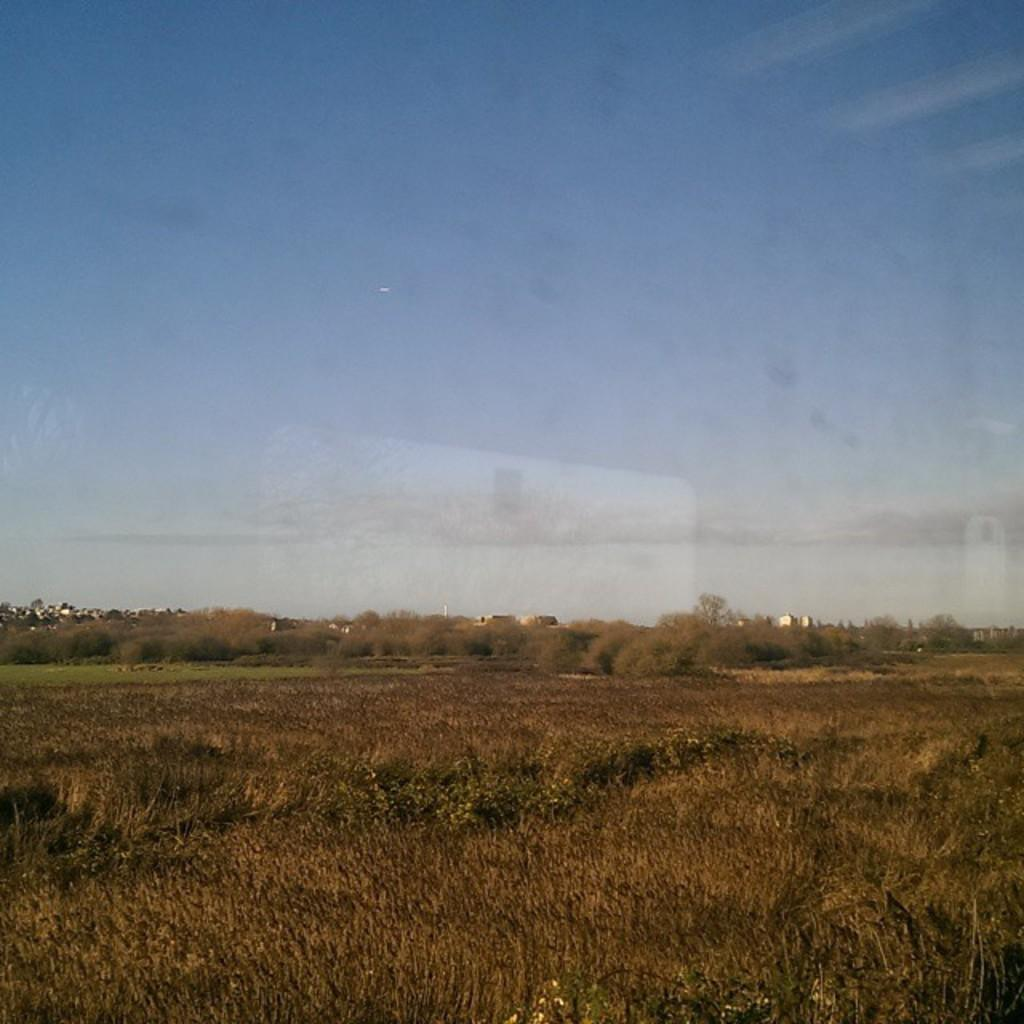What type of vegetation is visible in the image? There is grass in the image. What other natural elements can be seen in the image? There are trees in the image. What part of the natural environment is visible in the background of the image? The sky is visible in the background of the image. What type of engine can be seen in the image? There is no engine present in the image; it features grass, trees, and the sky. How many legs are visible in the image? There are no legs visible in the image; it features grass, trees, and the sky. 